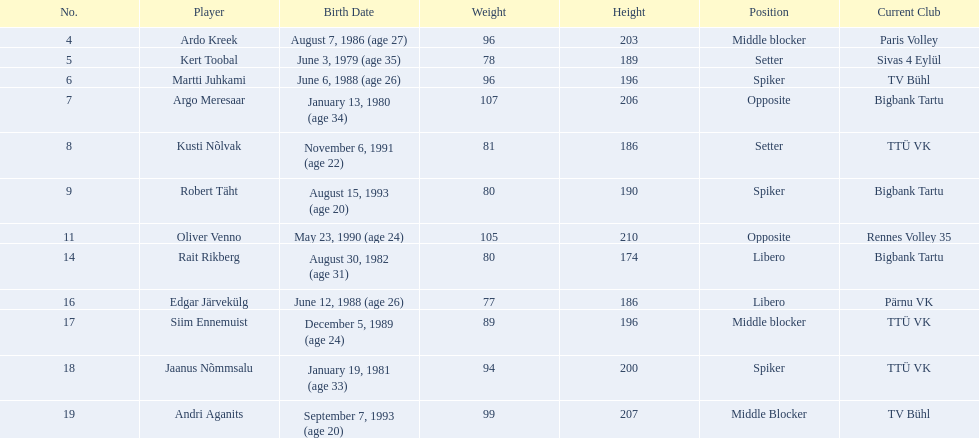Who are the members of the estonian men's national volleyball team? Ardo Kreek, Kert Toobal, Martti Juhkami, Argo Meresaar, Kusti Nõlvak, Robert Täht, Oliver Venno, Rait Rikberg, Edgar Järvekülg, Siim Ennemuist, Jaanus Nõmmsalu, Andri Aganits. Among them, who has a height above 200? Ardo Kreek, Argo Meresaar, Oliver Venno, Andri Aganits. Of the rest, who is the tallest? Oliver Venno. What are the statures in centimeters of the males in the group? 203, 189, 196, 206, 186, 190, 210, 174, 186, 196, 200, 207. What is the highest stature of a group member? 210. Which participant is at 210? Oliver Venno. 